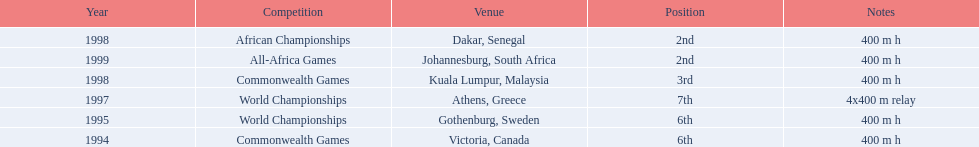What years did ken harder compete in? 1994, 1995, 1997, 1998, 1998, 1999. For the 1997 relay, what distance was ran? 4x400 m relay. 